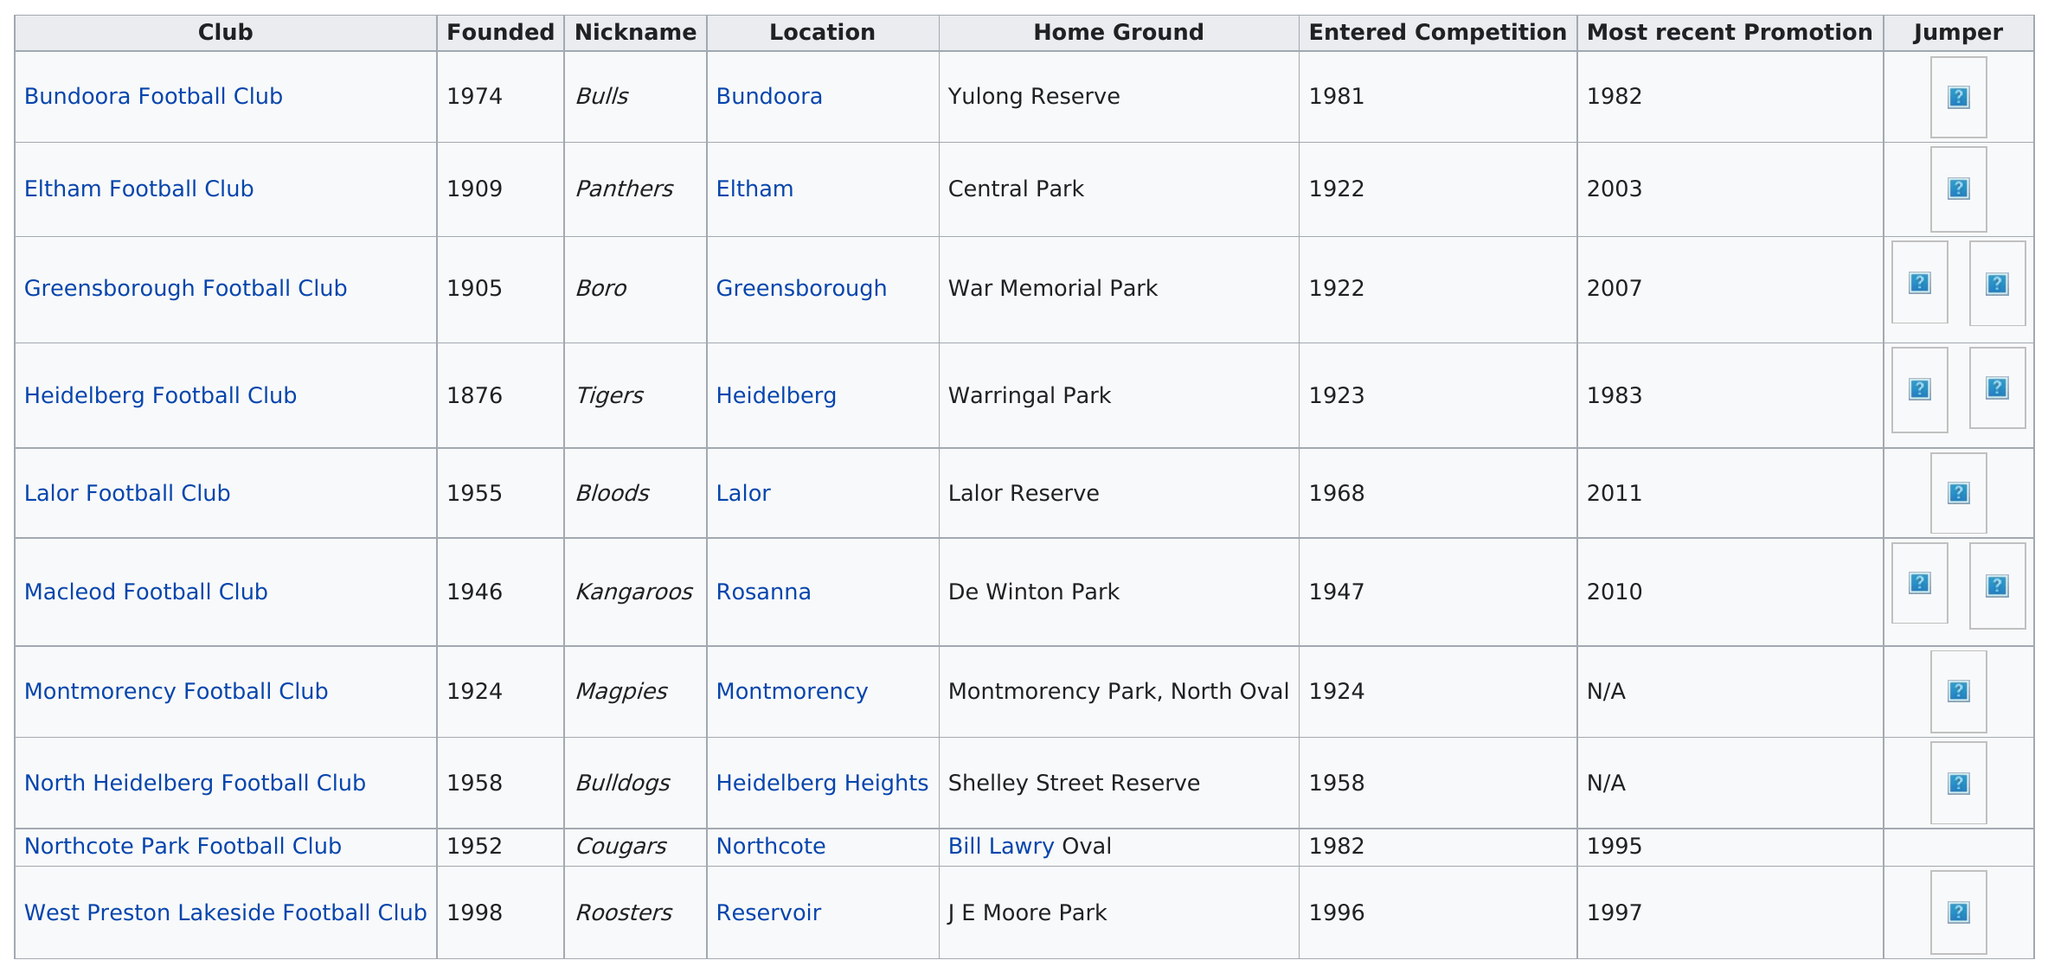Indicate a few pertinent items in this graphic. Eltham Football Club was established in the same year as Greensborough Football Club, which is a significant achievement for both clubs. The entry of Eltham Football Club into the competition reflects its dedication and perseverance in achieving its goals, while Greensborough Football Club's entry is a testament to its commitment to excellence in football. Heidelberg Football Club is the only division 1 team that was founded in the 1800s, making it a unique and historic team in the sport. It has been 7 years since the last Greensborough Football Club promotion. Northcote Park Football Club was the division 1 team in the 2010 Northern Football League season that was founded prior to the Lalor Football Club. The first Division 1 team to enter competition was Eltham Football Club and Greensborough Football Club. 